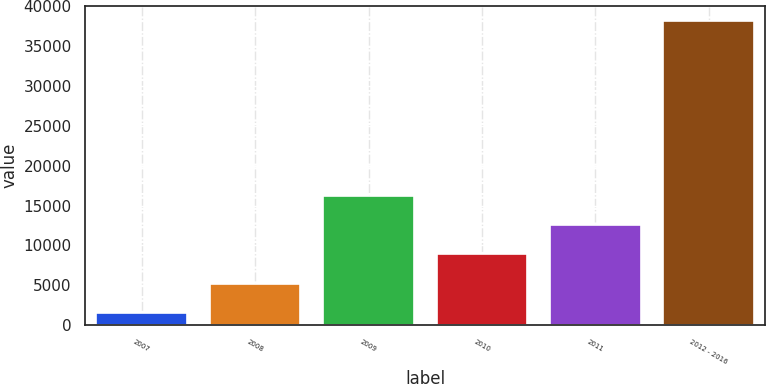<chart> <loc_0><loc_0><loc_500><loc_500><bar_chart><fcel>2007<fcel>2008<fcel>2009<fcel>2010<fcel>2011<fcel>2012 - 2016<nl><fcel>1553<fcel>5208.6<fcel>16175.4<fcel>8864.2<fcel>12519.8<fcel>38109<nl></chart> 